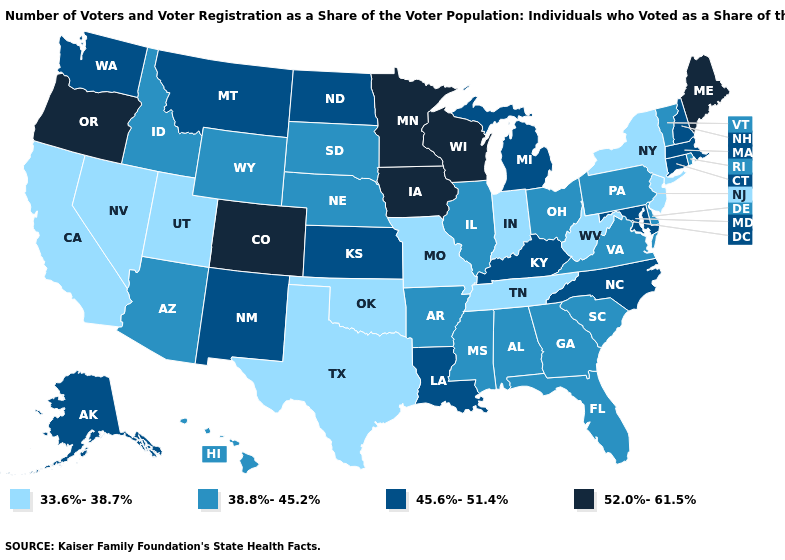Which states have the highest value in the USA?
Answer briefly. Colorado, Iowa, Maine, Minnesota, Oregon, Wisconsin. Which states have the lowest value in the South?
Keep it brief. Oklahoma, Tennessee, Texas, West Virginia. Does Texas have the lowest value in the South?
Quick response, please. Yes. What is the value of North Dakota?
Write a very short answer. 45.6%-51.4%. Does Pennsylvania have the same value as Nebraska?
Short answer required. Yes. How many symbols are there in the legend?
Concise answer only. 4. Which states have the lowest value in the USA?
Short answer required. California, Indiana, Missouri, Nevada, New Jersey, New York, Oklahoma, Tennessee, Texas, Utah, West Virginia. Does Maryland have a higher value than Wisconsin?
Answer briefly. No. What is the value of Connecticut?
Write a very short answer. 45.6%-51.4%. What is the value of Michigan?
Short answer required. 45.6%-51.4%. Does Texas have a higher value than Virginia?
Answer briefly. No. Is the legend a continuous bar?
Short answer required. No. Which states hav the highest value in the South?
Keep it brief. Kentucky, Louisiana, Maryland, North Carolina. What is the lowest value in the South?
Write a very short answer. 33.6%-38.7%. What is the highest value in the USA?
Keep it brief. 52.0%-61.5%. 